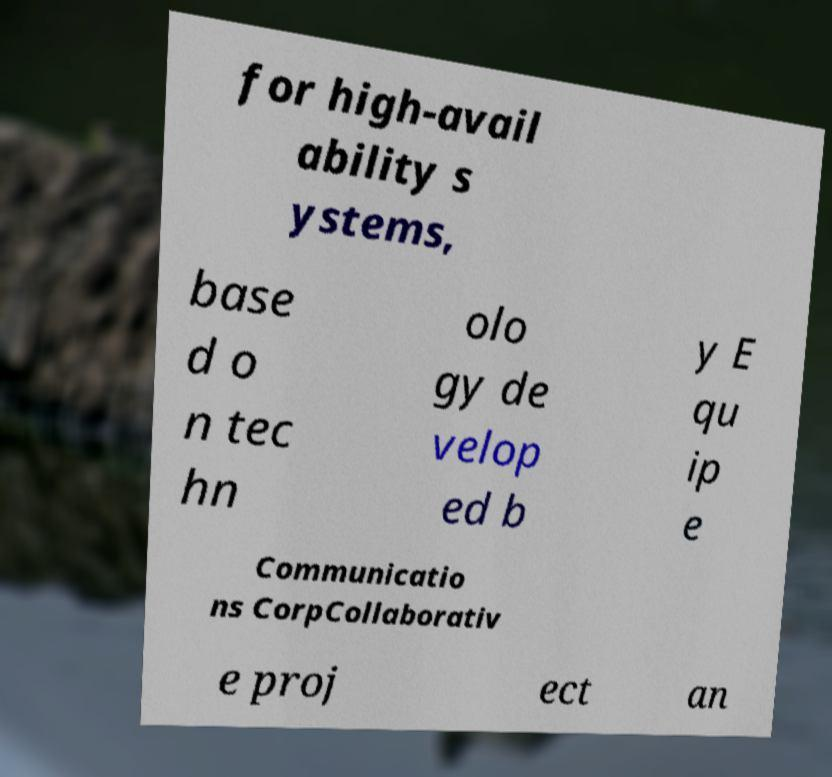For documentation purposes, I need the text within this image transcribed. Could you provide that? for high-avail ability s ystems, base d o n tec hn olo gy de velop ed b y E qu ip e Communicatio ns CorpCollaborativ e proj ect an 